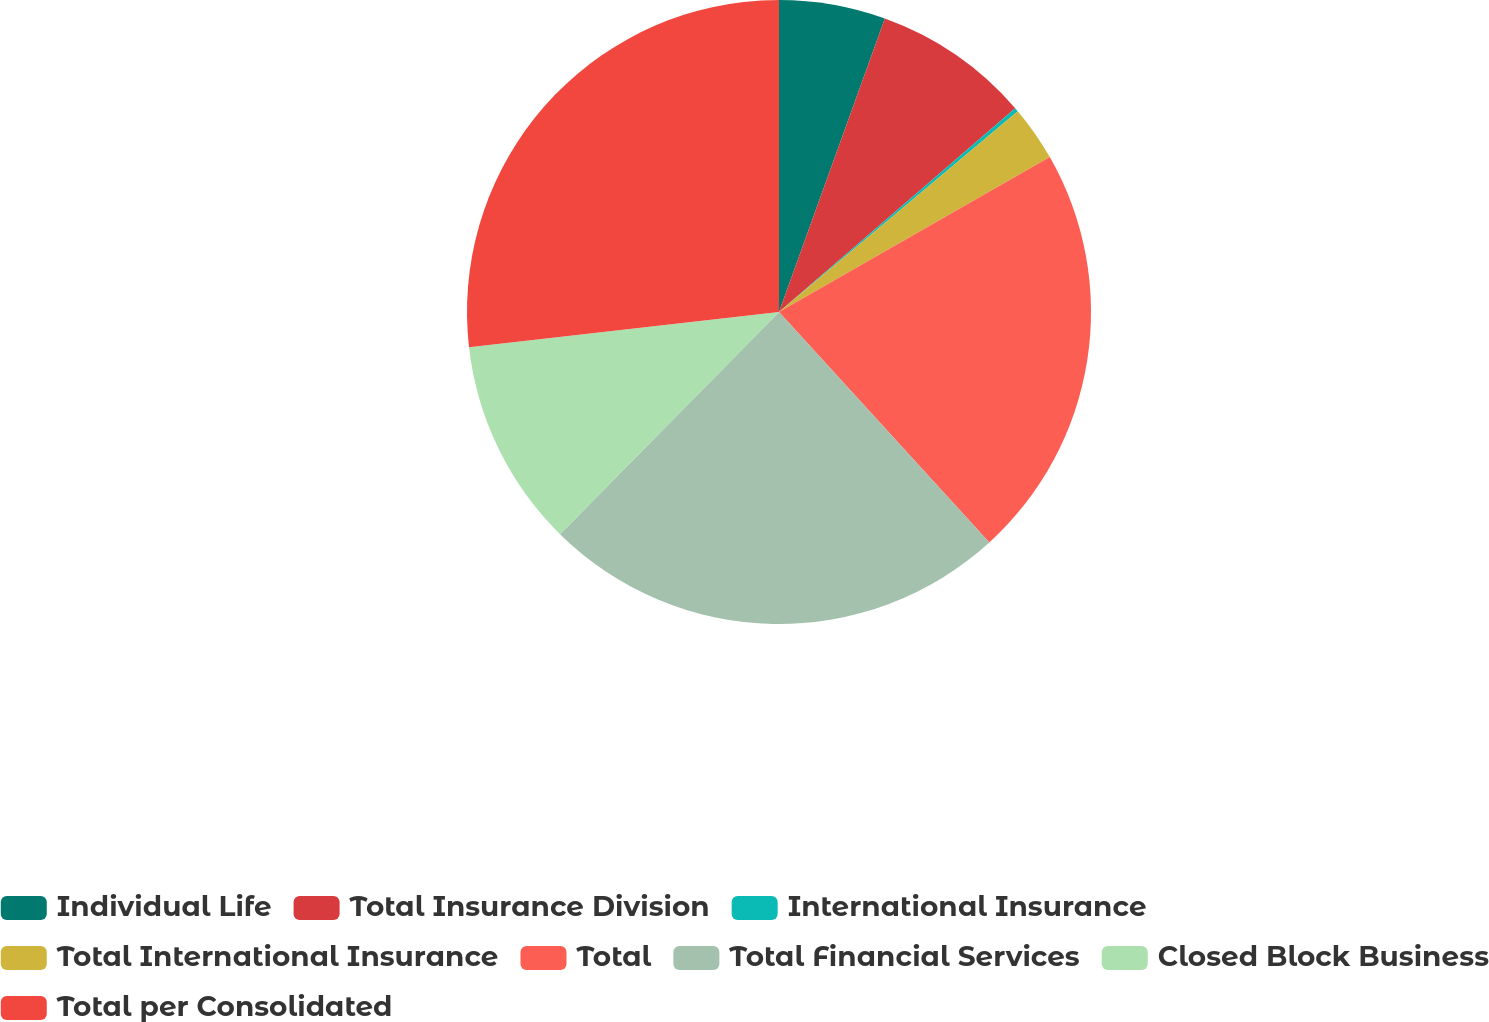Convert chart to OTSL. <chart><loc_0><loc_0><loc_500><loc_500><pie_chart><fcel>Individual Life<fcel>Total Insurance Division<fcel>International Insurance<fcel>Total International Insurance<fcel>Total<fcel>Total Financial Services<fcel>Closed Block Business<fcel>Total per Consolidated<nl><fcel>5.51%<fcel>8.16%<fcel>0.2%<fcel>2.86%<fcel>21.5%<fcel>24.16%<fcel>10.81%<fcel>26.81%<nl></chart> 